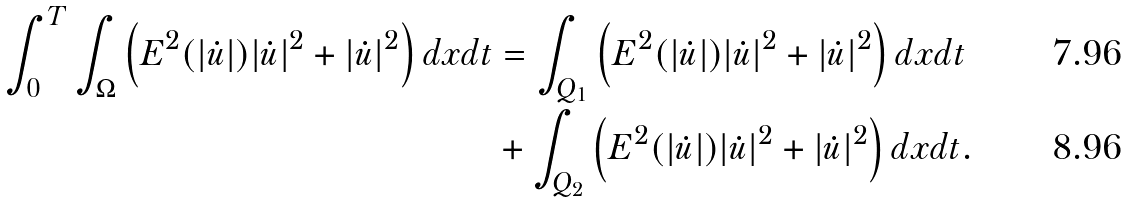<formula> <loc_0><loc_0><loc_500><loc_500>\int _ { 0 } ^ { T } \int _ { \Omega } \left ( E ^ { 2 } ( | \dot { u } | ) | \dot { u } | ^ { 2 } + | \dot { u } | ^ { 2 } \right ) d x d t & = \int _ { Q _ { 1 } } \left ( E ^ { 2 } ( | \dot { u } | ) | \dot { u } | ^ { 2 } + | \dot { u } | ^ { 2 } \right ) d x d t \\ & + \int _ { Q _ { 2 } } \left ( E ^ { 2 } ( | \dot { u } | ) | \dot { u } | ^ { 2 } + | \dot { u } | ^ { 2 } \right ) d x d t .</formula> 